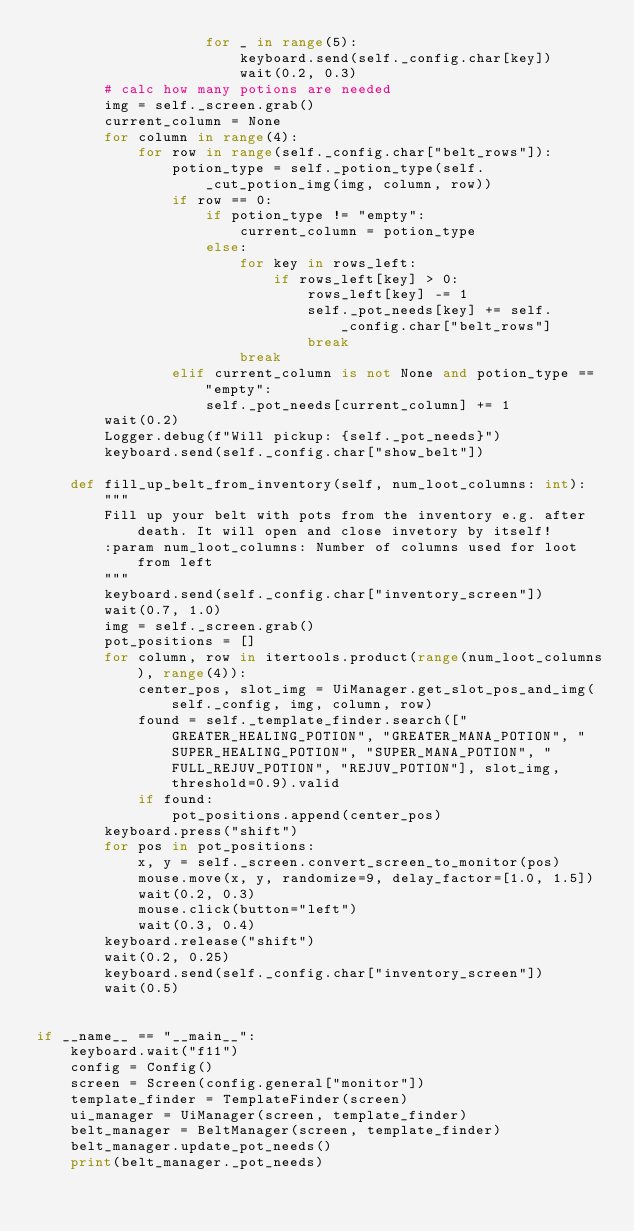Convert code to text. <code><loc_0><loc_0><loc_500><loc_500><_Python_>                    for _ in range(5):
                        keyboard.send(self._config.char[key])
                        wait(0.2, 0.3)
        # calc how many potions are needed
        img = self._screen.grab()
        current_column = None
        for column in range(4):
            for row in range(self._config.char["belt_rows"]):
                potion_type = self._potion_type(self._cut_potion_img(img, column, row))
                if row == 0:
                    if potion_type != "empty":
                        current_column = potion_type
                    else:
                        for key in rows_left:
                            if rows_left[key] > 0:
                                rows_left[key] -= 1
                                self._pot_needs[key] += self._config.char["belt_rows"]
                                break
                        break
                elif current_column is not None and potion_type == "empty":
                    self._pot_needs[current_column] += 1
        wait(0.2)
        Logger.debug(f"Will pickup: {self._pot_needs}")
        keyboard.send(self._config.char["show_belt"])

    def fill_up_belt_from_inventory(self, num_loot_columns: int):
        """
        Fill up your belt with pots from the inventory e.g. after death. It will open and close invetory by itself!
        :param num_loot_columns: Number of columns used for loot from left
        """
        keyboard.send(self._config.char["inventory_screen"])
        wait(0.7, 1.0)
        img = self._screen.grab()
        pot_positions = []
        for column, row in itertools.product(range(num_loot_columns), range(4)):
            center_pos, slot_img = UiManager.get_slot_pos_and_img(self._config, img, column, row)
            found = self._template_finder.search(["GREATER_HEALING_POTION", "GREATER_MANA_POTION", "SUPER_HEALING_POTION", "SUPER_MANA_POTION", "FULL_REJUV_POTION", "REJUV_POTION"], slot_img, threshold=0.9).valid
            if found:
                pot_positions.append(center_pos)
        keyboard.press("shift")
        for pos in pot_positions:
            x, y = self._screen.convert_screen_to_monitor(pos)
            mouse.move(x, y, randomize=9, delay_factor=[1.0, 1.5])
            wait(0.2, 0.3)
            mouse.click(button="left")
            wait(0.3, 0.4)
        keyboard.release("shift")
        wait(0.2, 0.25)
        keyboard.send(self._config.char["inventory_screen"])
        wait(0.5)


if __name__ == "__main__":
    keyboard.wait("f11")
    config = Config()
    screen = Screen(config.general["monitor"])
    template_finder = TemplateFinder(screen)
    ui_manager = UiManager(screen, template_finder)
    belt_manager = BeltManager(screen, template_finder)
    belt_manager.update_pot_needs()
    print(belt_manager._pot_needs)
</code> 